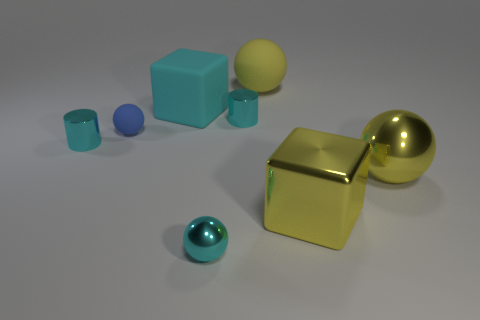How big is the metallic sphere that is on the right side of the yellow rubber object that is behind the large ball right of the big yellow shiny block?
Provide a succinct answer. Large. There is a large yellow shiny cube; are there any large yellow metallic spheres in front of it?
Make the answer very short. No. What is the shape of the shiny thing that is the same color as the shiny cube?
Offer a terse response. Sphere. What number of objects are either small cyan shiny things that are to the right of the cyan sphere or cyan rubber things?
Your response must be concise. 2. There is a yellow object that is made of the same material as the blue ball; what size is it?
Offer a very short reply. Large. Does the rubber block have the same size as the cyan thing that is in front of the yellow metal ball?
Provide a short and direct response. No. What is the color of the metal thing that is both in front of the big metal ball and behind the cyan ball?
Ensure brevity in your answer.  Yellow. How many objects are either metallic things behind the small rubber ball or small cyan cylinders that are to the right of the tiny cyan ball?
Offer a terse response. 1. The cube that is on the right side of the metallic ball to the left of the rubber ball that is behind the cyan rubber object is what color?
Your answer should be very brief. Yellow. Is there another blue object that has the same shape as the tiny blue object?
Give a very brief answer. No. 